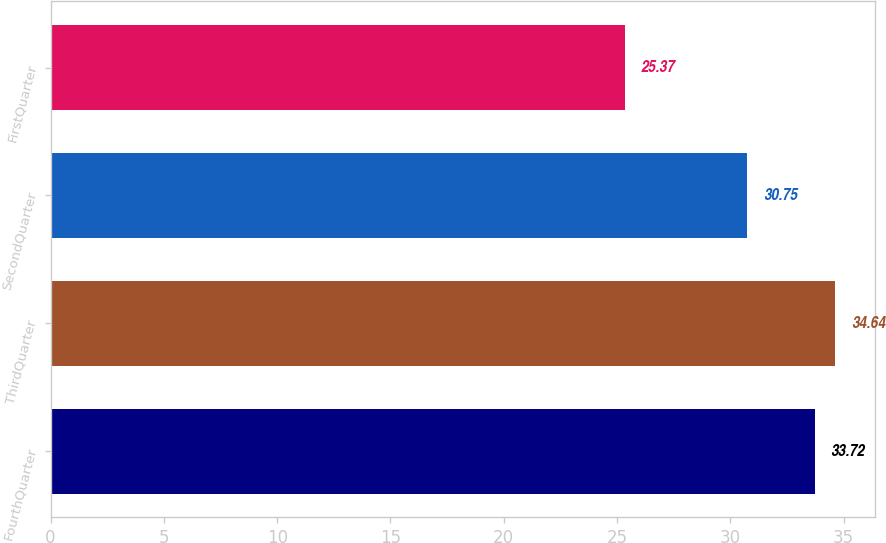<chart> <loc_0><loc_0><loc_500><loc_500><bar_chart><fcel>FourthQuarter<fcel>ThirdQuarter<fcel>SecondQuarter<fcel>FirstQuarter<nl><fcel>33.72<fcel>34.64<fcel>30.75<fcel>25.37<nl></chart> 